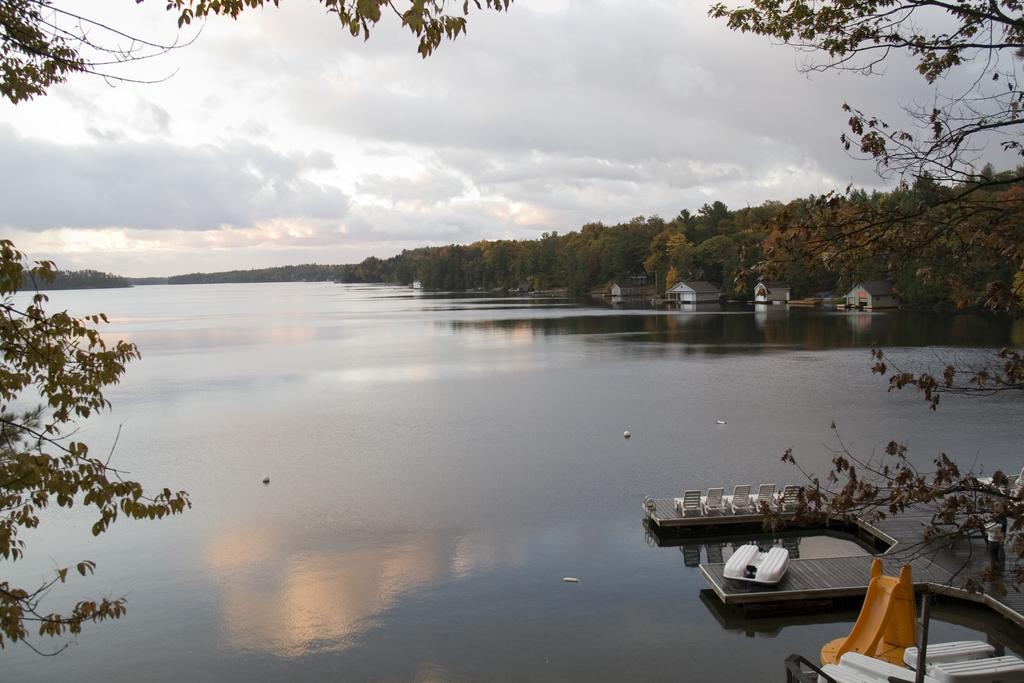In one or two sentences, can you explain what this image depicts? This looks like a river with the water. These are the trees with branches and leaves. This looks like a wooden platform. I can see the benches and chairs. I think these are the houses. This is the sky with the clouds. 